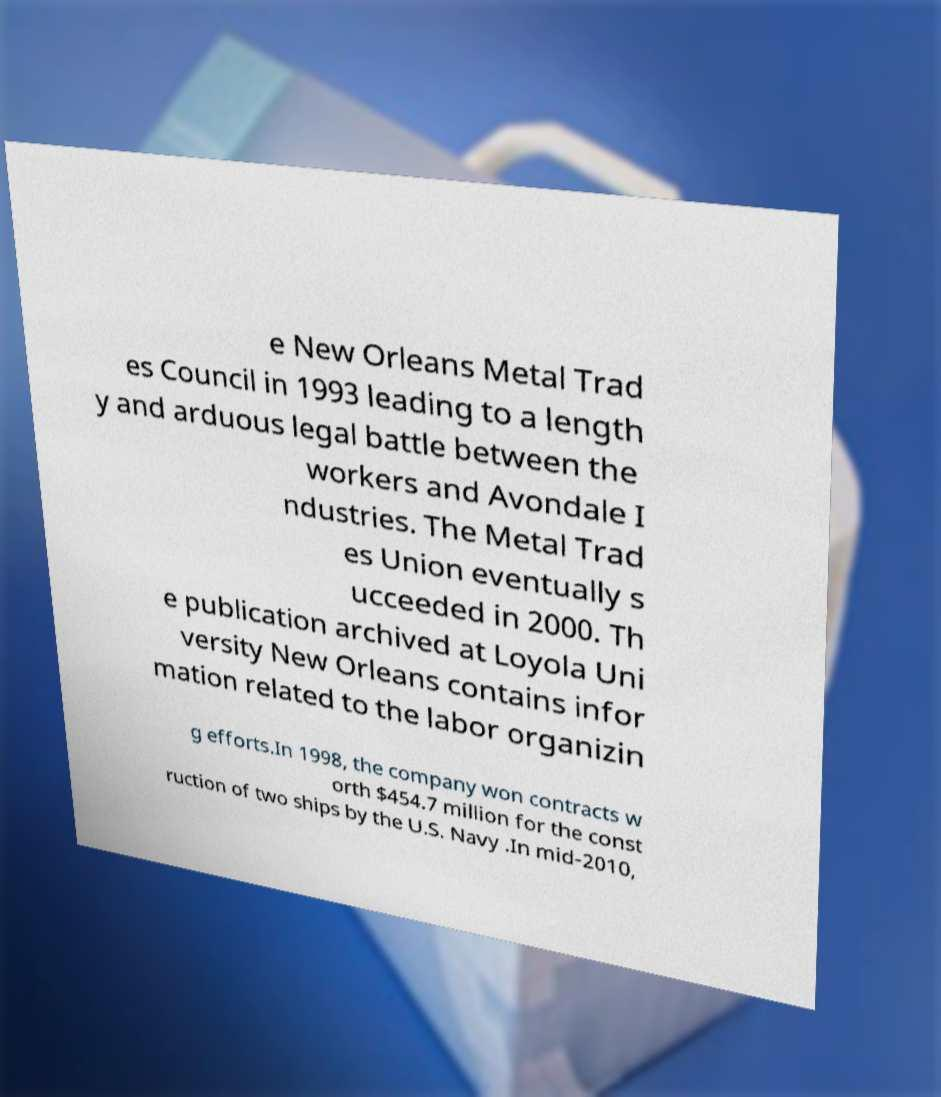Can you read and provide the text displayed in the image?This photo seems to have some interesting text. Can you extract and type it out for me? e New Orleans Metal Trad es Council in 1993 leading to a length y and arduous legal battle between the workers and Avondale I ndustries. The Metal Trad es Union eventually s ucceeded in 2000. Th e publication archived at Loyola Uni versity New Orleans contains infor mation related to the labor organizin g efforts.In 1998, the company won contracts w orth $454.7 million for the const ruction of two ships by the U.S. Navy .In mid-2010, 